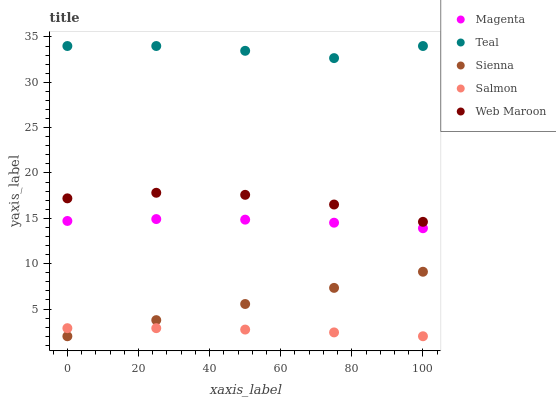Does Salmon have the minimum area under the curve?
Answer yes or no. Yes. Does Teal have the maximum area under the curve?
Answer yes or no. Yes. Does Web Maroon have the minimum area under the curve?
Answer yes or no. No. Does Web Maroon have the maximum area under the curve?
Answer yes or no. No. Is Sienna the smoothest?
Answer yes or no. Yes. Is Teal the roughest?
Answer yes or no. Yes. Is Web Maroon the smoothest?
Answer yes or no. No. Is Web Maroon the roughest?
Answer yes or no. No. Does Sienna have the lowest value?
Answer yes or no. Yes. Does Web Maroon have the lowest value?
Answer yes or no. No. Does Teal have the highest value?
Answer yes or no. Yes. Does Web Maroon have the highest value?
Answer yes or no. No. Is Web Maroon less than Teal?
Answer yes or no. Yes. Is Web Maroon greater than Magenta?
Answer yes or no. Yes. Does Sienna intersect Salmon?
Answer yes or no. Yes. Is Sienna less than Salmon?
Answer yes or no. No. Is Sienna greater than Salmon?
Answer yes or no. No. Does Web Maroon intersect Teal?
Answer yes or no. No. 